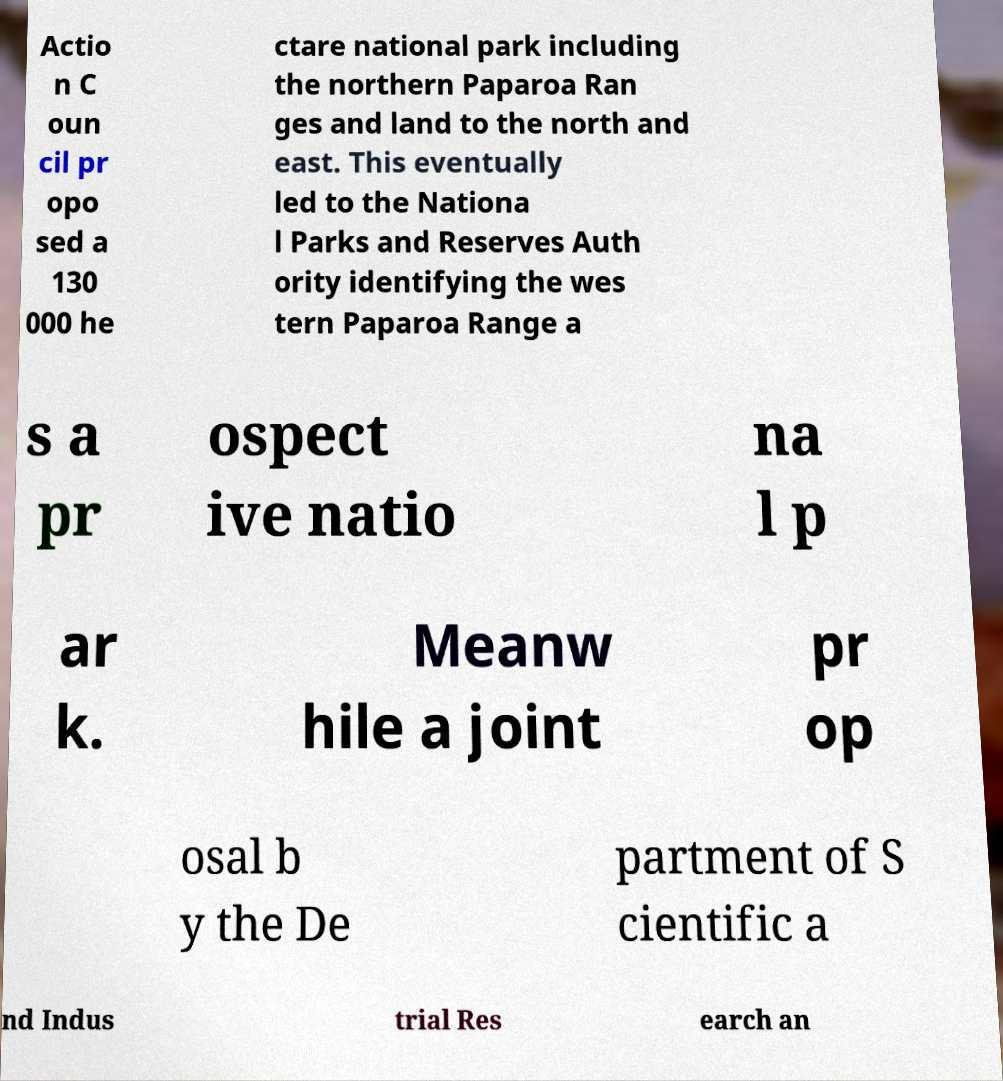Please read and relay the text visible in this image. What does it say? Actio n C oun cil pr opo sed a 130 000 he ctare national park including the northern Paparoa Ran ges and land to the north and east. This eventually led to the Nationa l Parks and Reserves Auth ority identifying the wes tern Paparoa Range a s a pr ospect ive natio na l p ar k. Meanw hile a joint pr op osal b y the De partment of S cientific a nd Indus trial Res earch an 